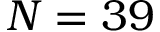Convert formula to latex. <formula><loc_0><loc_0><loc_500><loc_500>N = 3 9</formula> 